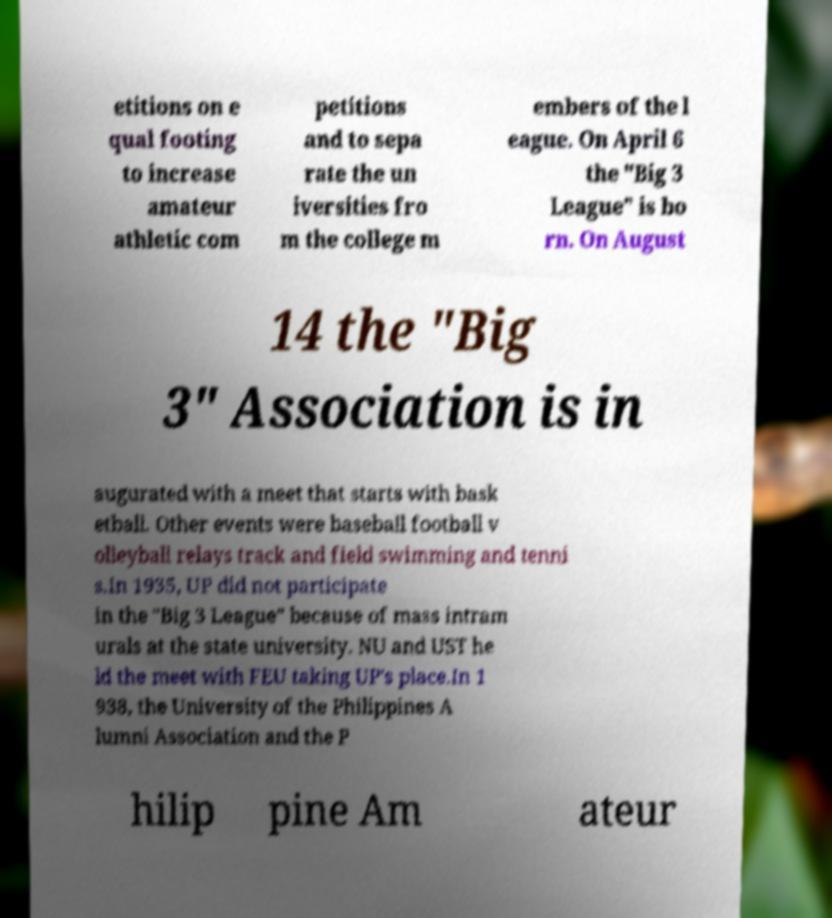Can you read and provide the text displayed in the image?This photo seems to have some interesting text. Can you extract and type it out for me? etitions on e qual footing to increase amateur athletic com petitions and to sepa rate the un iversities fro m the college m embers of the l eague. On April 6 the "Big 3 League" is bo rn. On August 14 the "Big 3" Association is in augurated with a meet that starts with bask etball. Other events were baseball football v olleyball relays track and field swimming and tenni s.In 1935, UP did not participate in the "Big 3 League" because of mass intram urals at the state university. NU and UST he ld the meet with FEU taking UP's place.In 1 938, the University of the Philippines A lumni Association and the P hilip pine Am ateur 